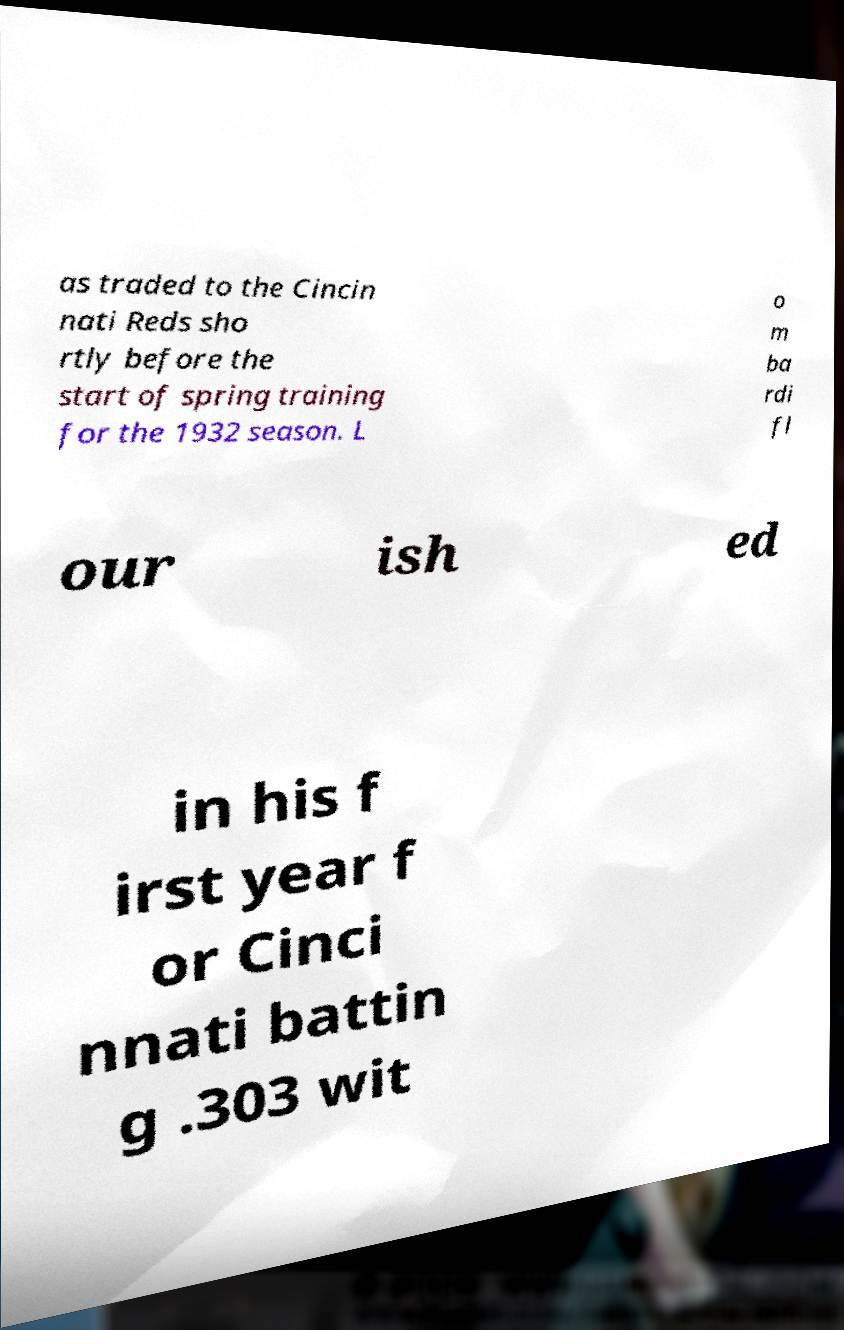Could you extract and type out the text from this image? as traded to the Cincin nati Reds sho rtly before the start of spring training for the 1932 season. L o m ba rdi fl our ish ed in his f irst year f or Cinci nnati battin g .303 wit 